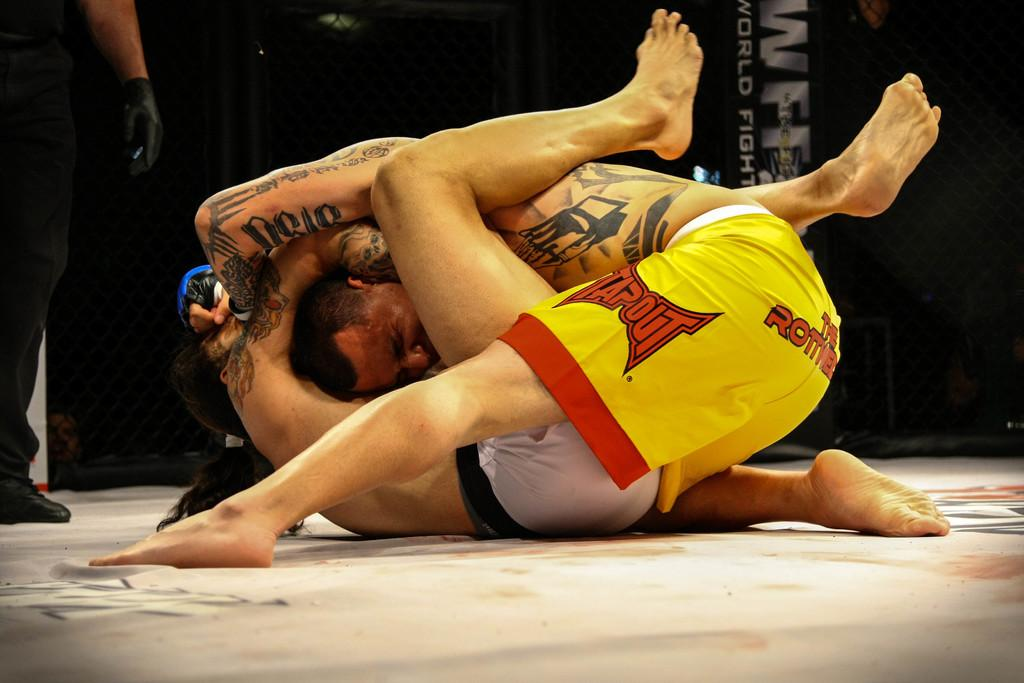Provide a one-sentence caption for the provided image. a person with yellow shorts that says Tapout on it. 